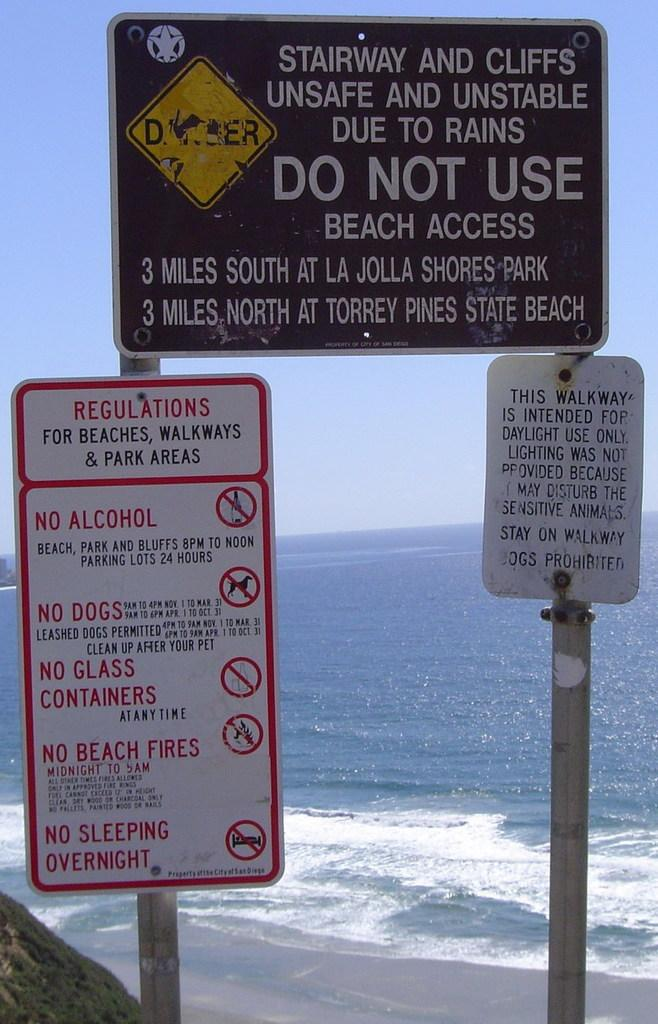<image>
Give a short and clear explanation of the subsequent image. several warning signs at beach, one warning stairway and cliffs unsafe and unstable due to rains 